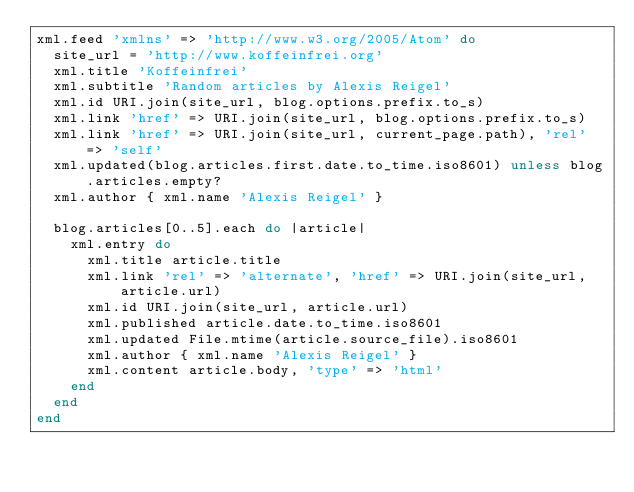Convert code to text. <code><loc_0><loc_0><loc_500><loc_500><_Ruby_>xml.feed 'xmlns' => 'http://www.w3.org/2005/Atom' do
  site_url = 'http://www.koffeinfrei.org'
  xml.title 'Koffeinfrei'
  xml.subtitle 'Random articles by Alexis Reigel'
  xml.id URI.join(site_url, blog.options.prefix.to_s)
  xml.link 'href' => URI.join(site_url, blog.options.prefix.to_s)
  xml.link 'href' => URI.join(site_url, current_page.path), 'rel' => 'self'
  xml.updated(blog.articles.first.date.to_time.iso8601) unless blog.articles.empty?
  xml.author { xml.name 'Alexis Reigel' }

  blog.articles[0..5].each do |article|
    xml.entry do
      xml.title article.title
      xml.link 'rel' => 'alternate', 'href' => URI.join(site_url, article.url)
      xml.id URI.join(site_url, article.url)
      xml.published article.date.to_time.iso8601
      xml.updated File.mtime(article.source_file).iso8601
      xml.author { xml.name 'Alexis Reigel' }
      xml.content article.body, 'type' => 'html'
    end
  end
end
</code> 